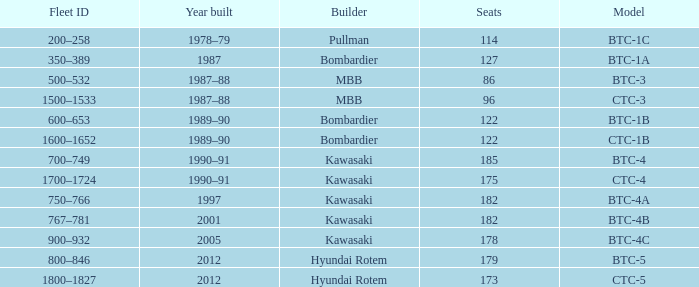In which year was the construction of the ctc-3 model completed? 1987–88. 